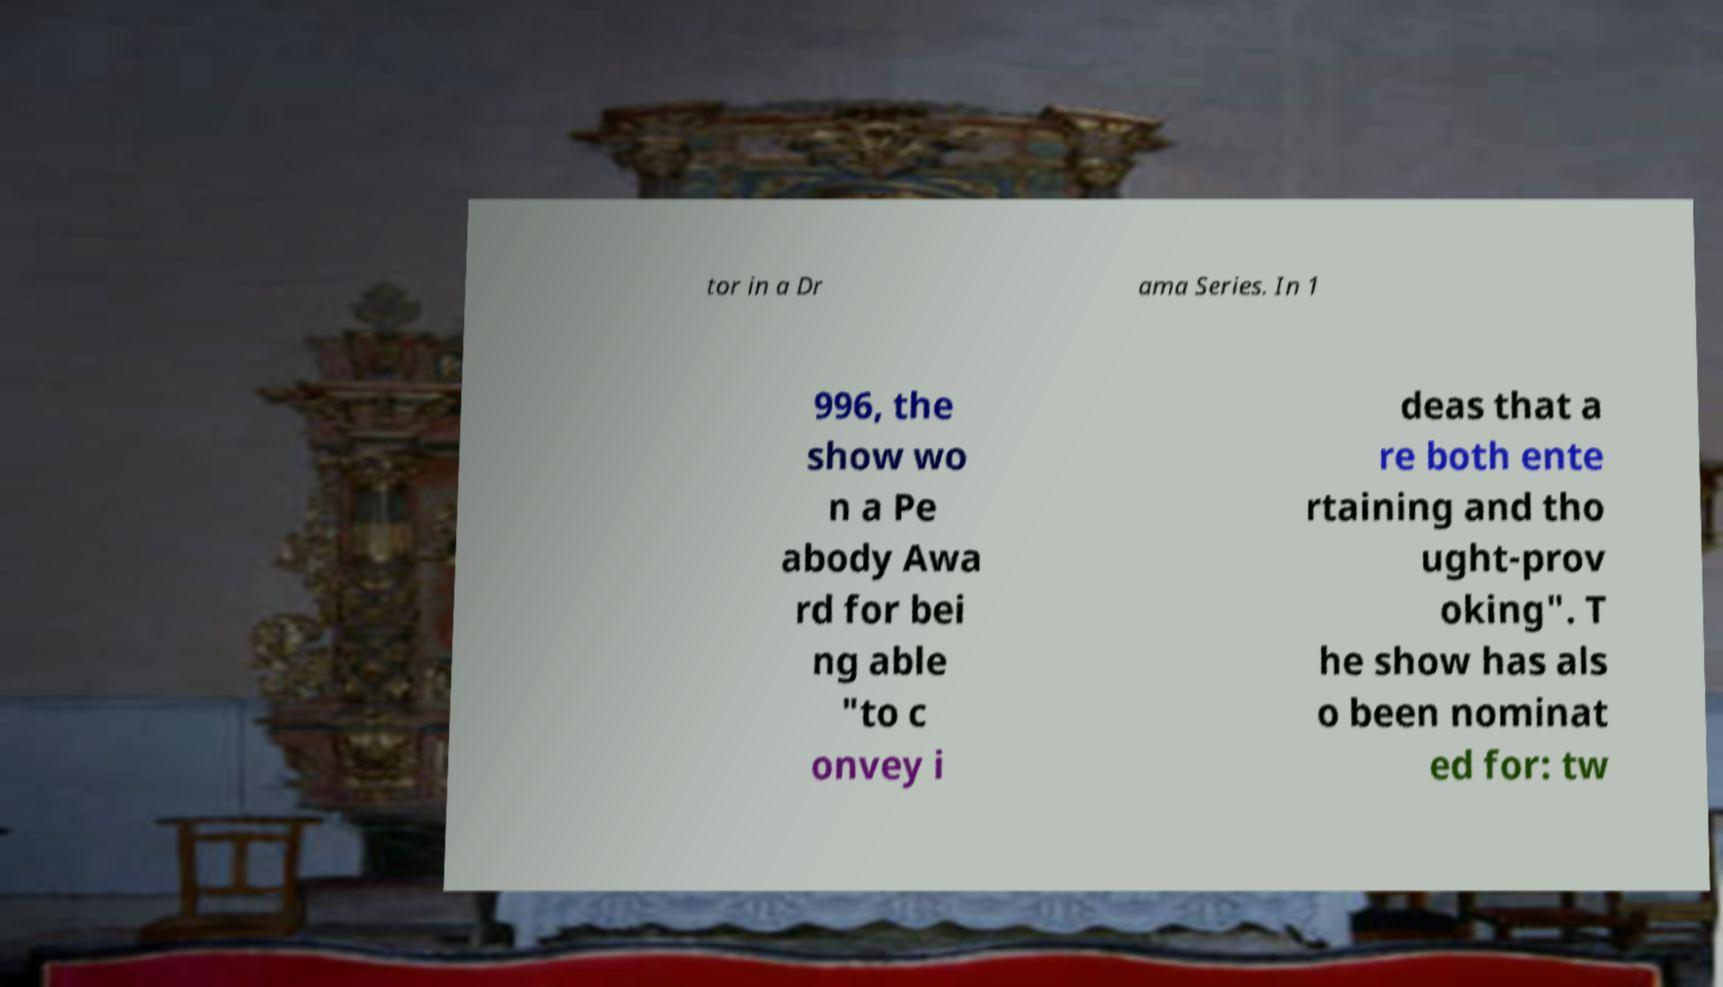Could you assist in decoding the text presented in this image and type it out clearly? tor in a Dr ama Series. In 1 996, the show wo n a Pe abody Awa rd for bei ng able "to c onvey i deas that a re both ente rtaining and tho ught-prov oking". T he show has als o been nominat ed for: tw 